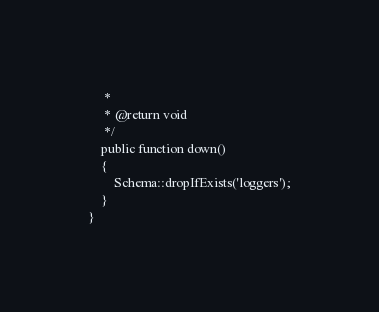Convert code to text. <code><loc_0><loc_0><loc_500><loc_500><_PHP_>     *
     * @return void
     */
    public function down()
    {
        Schema::dropIfExists('loggers');
    }
}
</code> 